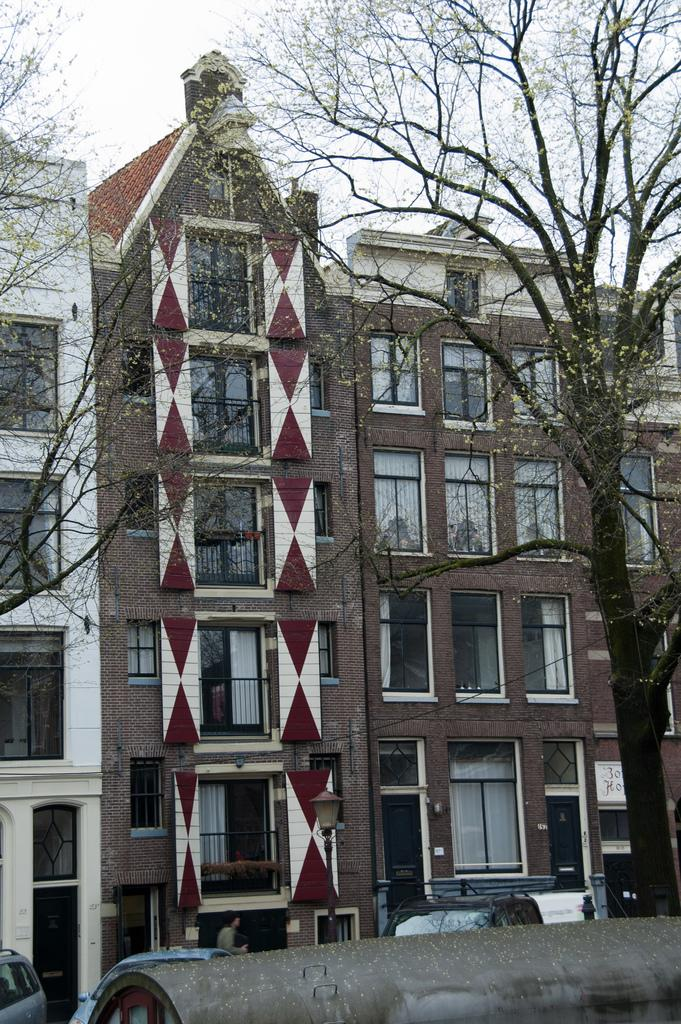What is the main structure in the middle of the image? There is a building in the middle of the image. What features can be seen on the building? The building has doors and windows. What is visible at the top of the image? The sky is visible at the top of the image. What type of vegetation is present in the middle of the image? There are trees in the middle of the image. What can be seen at the bottom of the image? There are cars at the bottom of the image. What type of lunch is being served in the bucket in the image? There is no bucket or lunch present in the image. 